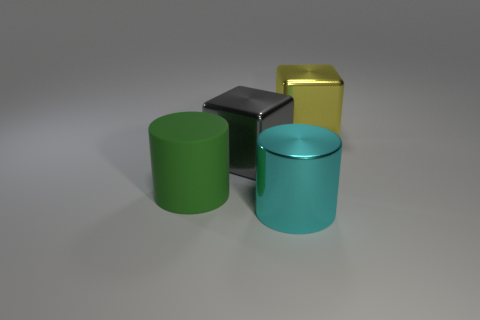Add 2 big gray metallic things. How many objects exist? 6 Subtract all large gray metallic objects. Subtract all big blue rubber cylinders. How many objects are left? 3 Add 3 large shiny cylinders. How many large shiny cylinders are left? 4 Add 3 tiny gray objects. How many tiny gray objects exist? 3 Subtract 0 purple cubes. How many objects are left? 4 